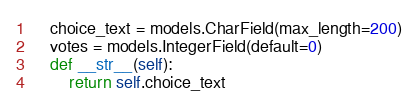<code> <loc_0><loc_0><loc_500><loc_500><_Python_>    choice_text = models.CharField(max_length=200)
    votes = models.IntegerField(default=0)
    def __str__(self):
        return self.choice_text

</code> 